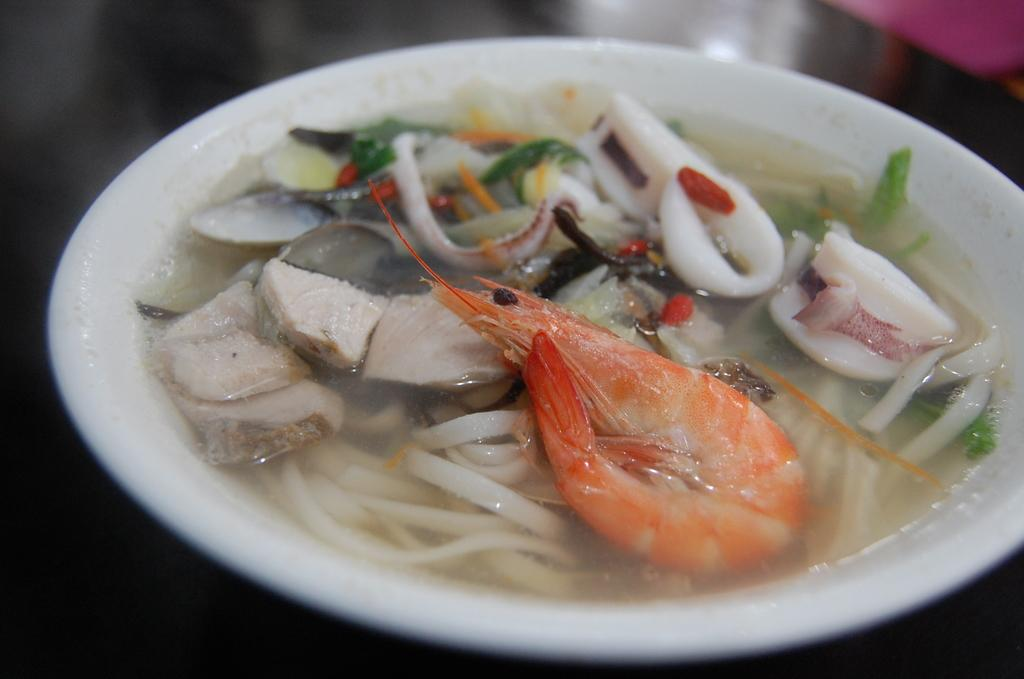What type of objects can be seen in the image? There are food items in the image. How are the food items arranged or contained? The food items are in a white color bowl. What type of wine is being served in the image? There is no wine present in the image; it only features food items in a white color bowl. 